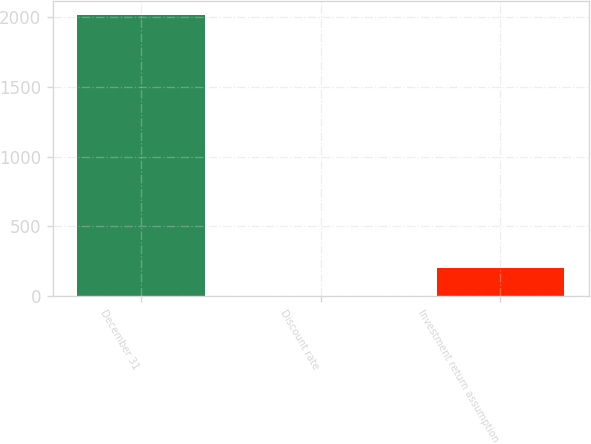<chart> <loc_0><loc_0><loc_500><loc_500><bar_chart><fcel>December 31<fcel>Discount rate<fcel>Investment return assumption<nl><fcel>2012<fcel>5.1<fcel>205.79<nl></chart> 